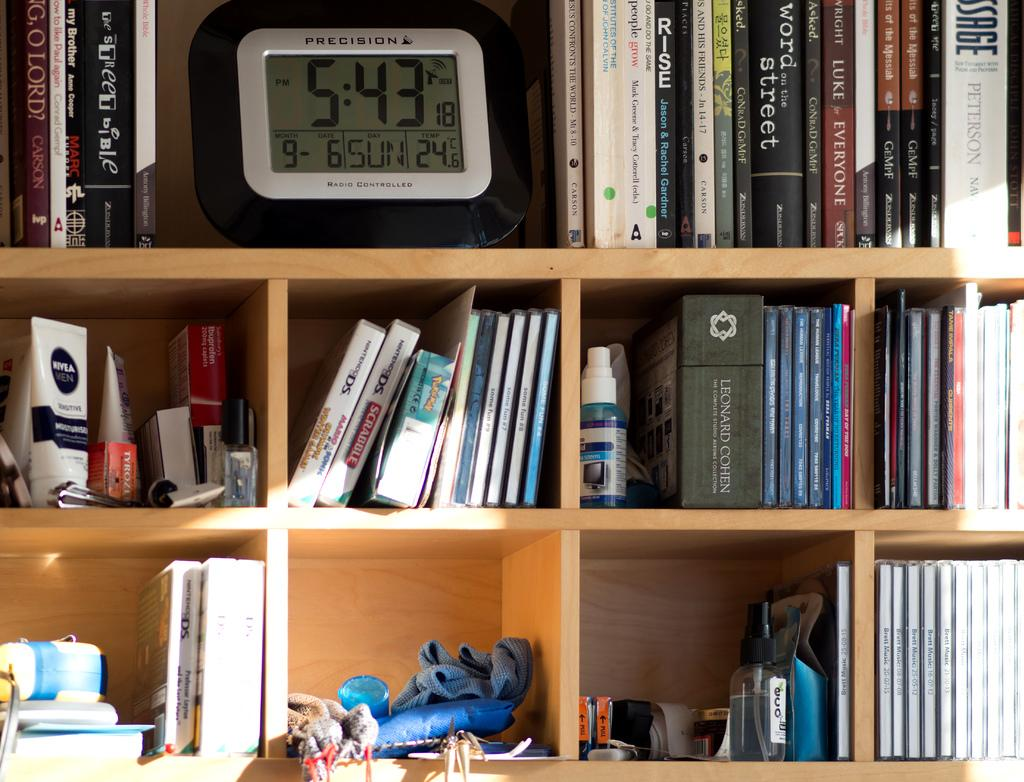<image>
Share a concise interpretation of the image provided. A digital clock on a bookshelf is made by a company called Precision. 